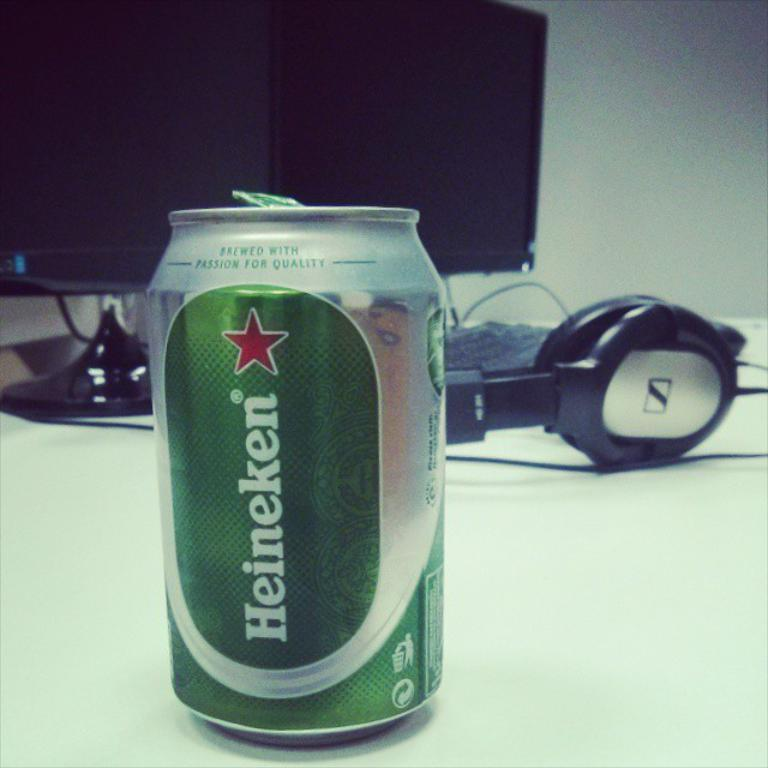<image>
Offer a succinct explanation of the picture presented. a can of Heineken beer in front of a headset 